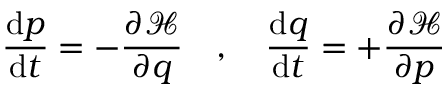<formula> <loc_0><loc_0><loc_500><loc_500>{ \frac { d { p } } { d t } } = - { \frac { \partial { \mathcal { H } } } { \partial { q } } } \quad , \quad \frac { d { q } } { d t } = + { \frac { \partial { \mathcal { H } } } { \partial { p } } }</formula> 